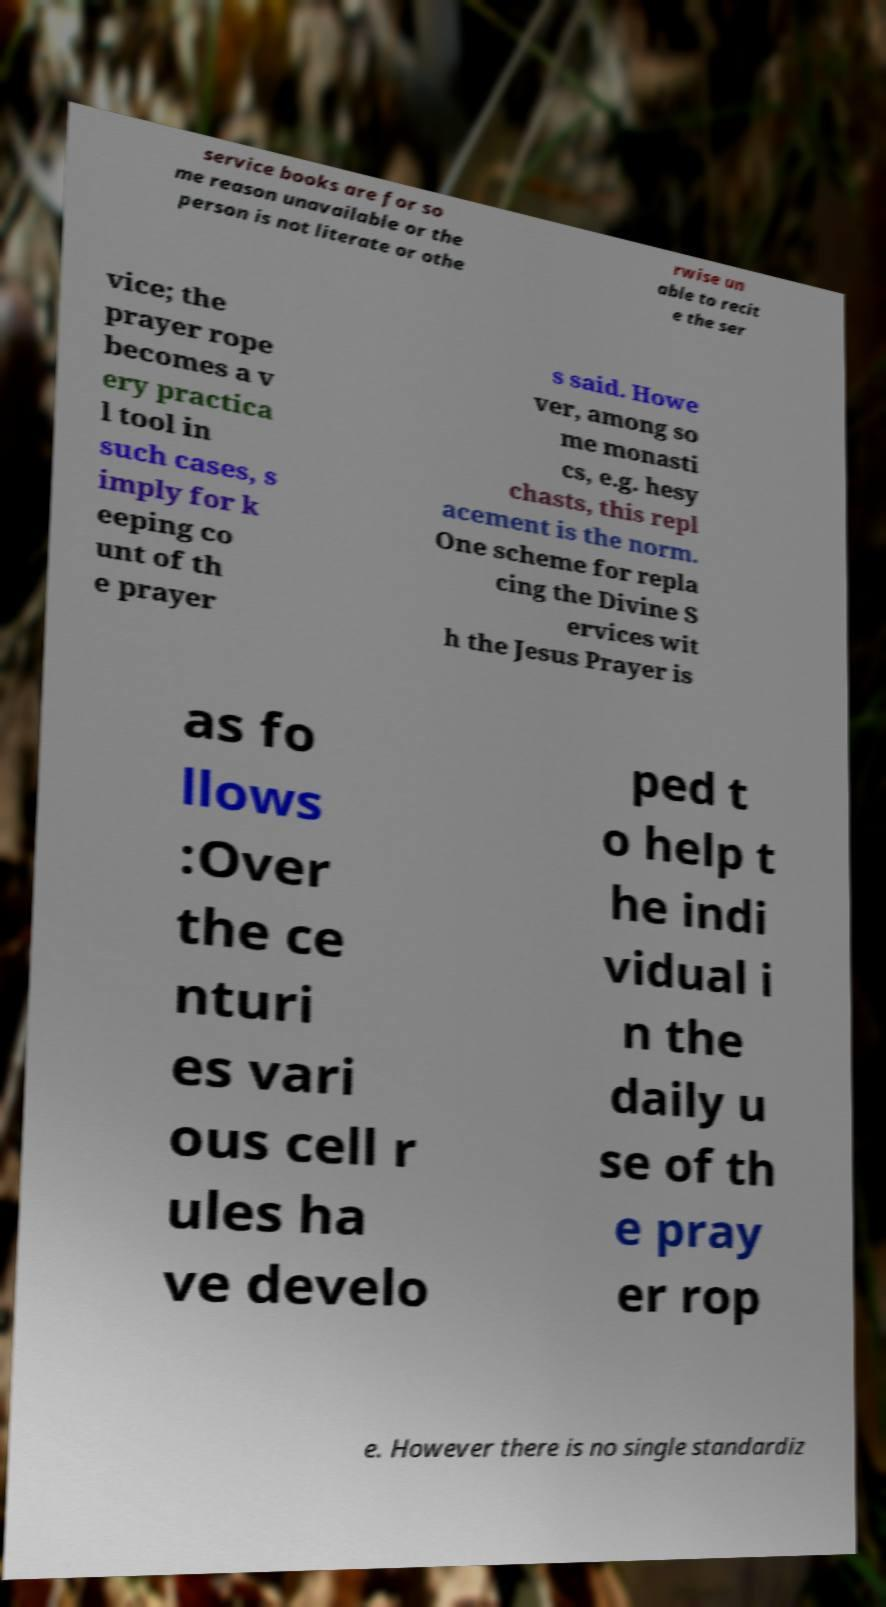Please read and relay the text visible in this image. What does it say? service books are for so me reason unavailable or the person is not literate or othe rwise un able to recit e the ser vice; the prayer rope becomes a v ery practica l tool in such cases, s imply for k eeping co unt of th e prayer s said. Howe ver, among so me monasti cs, e.g. hesy chasts, this repl acement is the norm. One scheme for repla cing the Divine S ervices wit h the Jesus Prayer is as fo llows :Over the ce nturi es vari ous cell r ules ha ve develo ped t o help t he indi vidual i n the daily u se of th e pray er rop e. However there is no single standardiz 